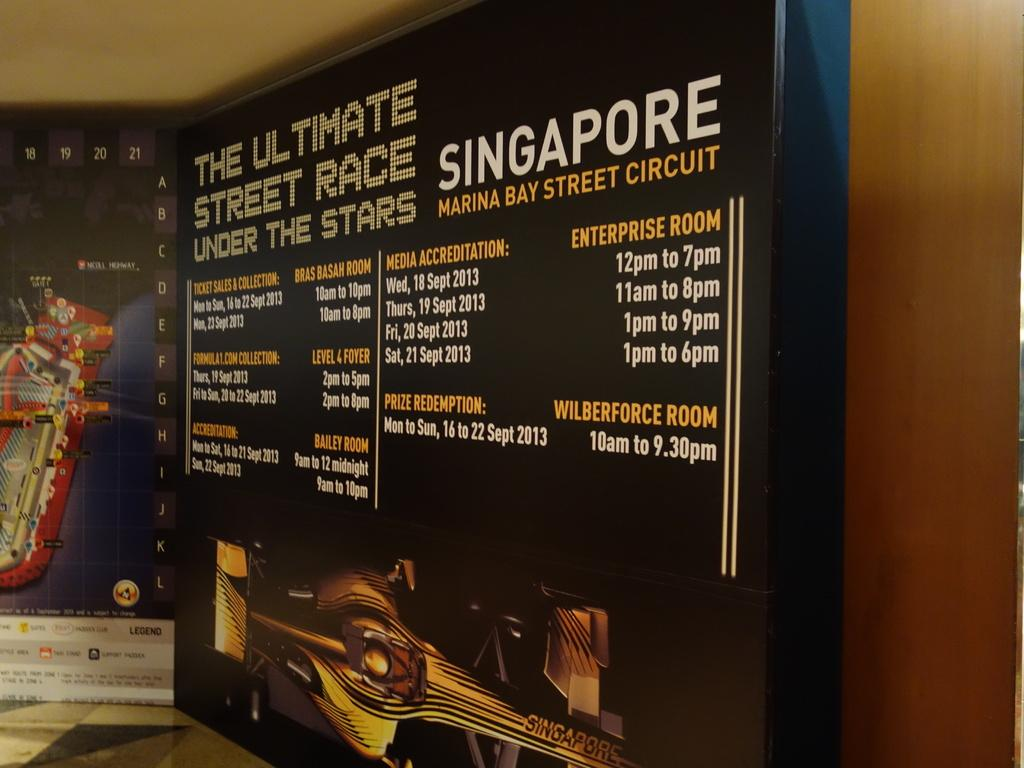<image>
Present a compact description of the photo's key features. A sign that reads The ultimat street race under the stars in singapore with a black background. 